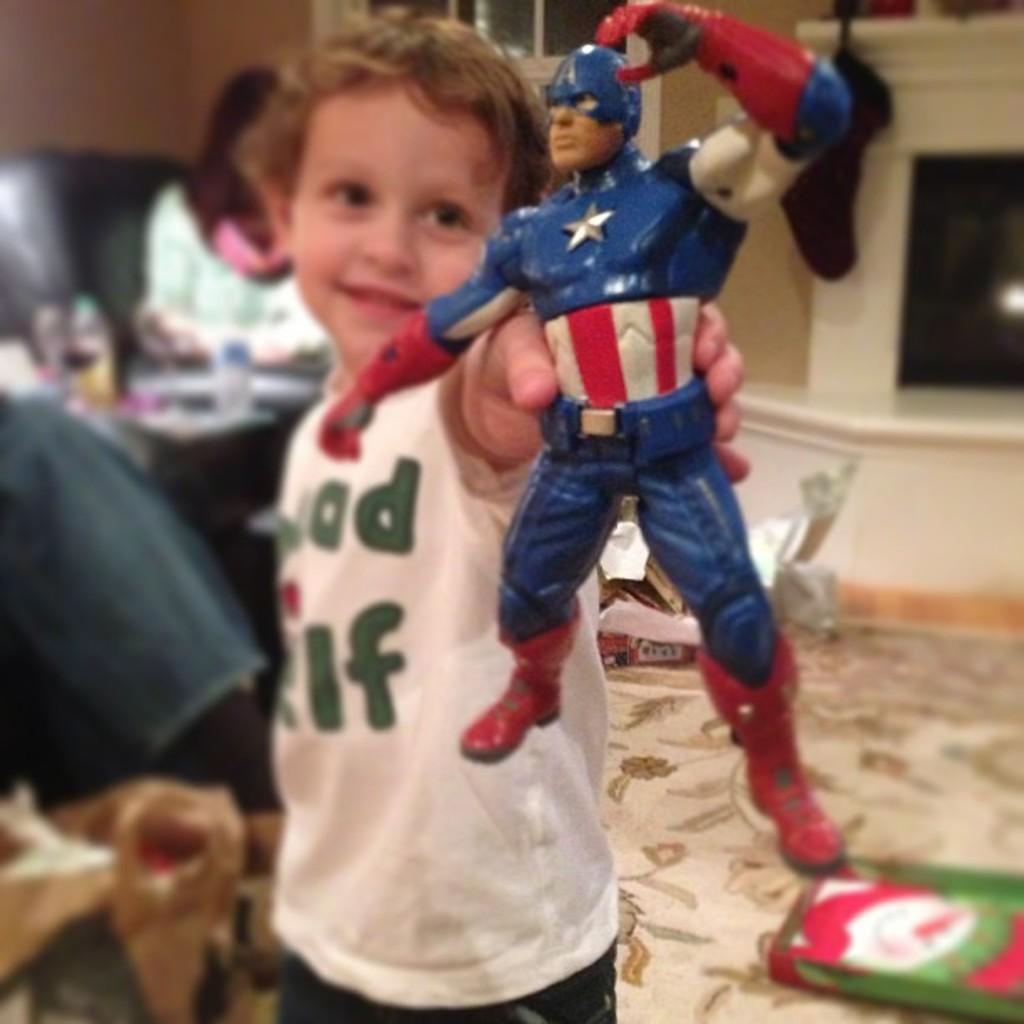Describe this image in one or two sentences. This is the picture of a room. In this image there is a boy standing and smiling and he is holding the toy. At the back there is a person sitting. There are bottles and some objects on the table. At the back there is a door. At the bottom there are boxes on the mat. 